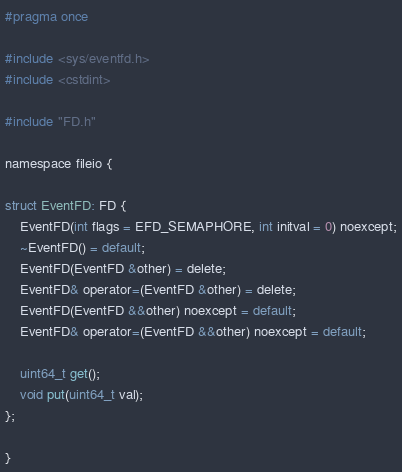Convert code to text. <code><loc_0><loc_0><loc_500><loc_500><_C_>#pragma once

#include <sys/eventfd.h>
#include <cstdint>

#include "FD.h"

namespace fileio {

struct EventFD: FD {
    EventFD(int flags = EFD_SEMAPHORE, int initval = 0) noexcept;
    ~EventFD() = default;
    EventFD(EventFD &other) = delete;
    EventFD& operator=(EventFD &other) = delete;
    EventFD(EventFD &&other) noexcept = default;
    EventFD& operator=(EventFD &&other) noexcept = default;

    uint64_t get();
    void put(uint64_t val);
};

}
</code> 